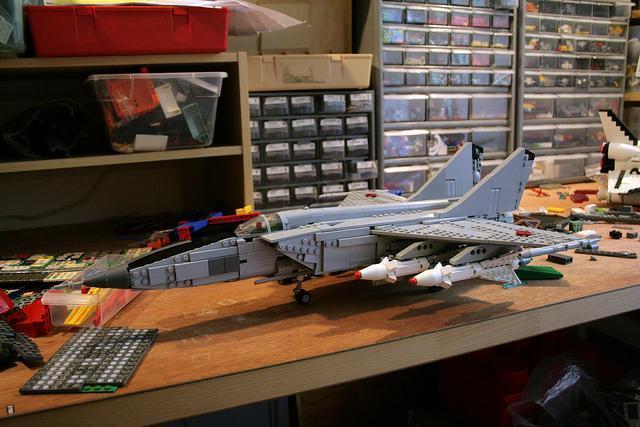How many people will ride in this plane?
Give a very brief answer. 0. How many of the people on the closest bench are talking?
Give a very brief answer. 0. 